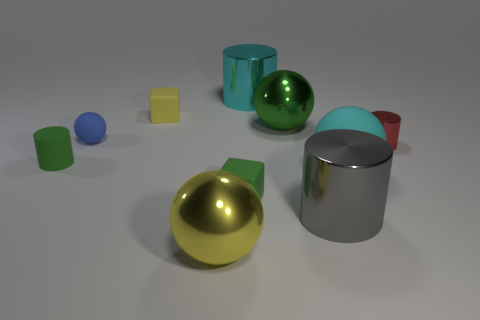Subtract all gray cylinders. How many cylinders are left? 3 Subtract all tiny blue matte spheres. How many spheres are left? 3 Subtract 1 cylinders. How many cylinders are left? 3 Subtract all gray spheres. Subtract all cyan blocks. How many spheres are left? 4 Subtract all cubes. How many objects are left? 8 Add 6 small blue metallic things. How many small blue metallic things exist? 6 Subtract 1 cyan balls. How many objects are left? 9 Subtract all big purple cylinders. Subtract all big cyan spheres. How many objects are left? 9 Add 4 cyan cylinders. How many cyan cylinders are left? 5 